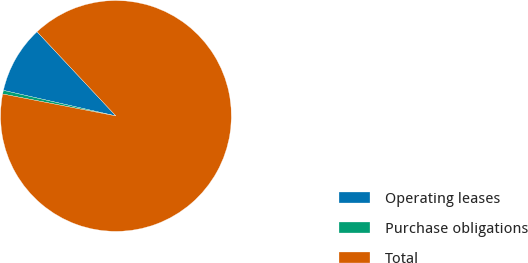Convert chart to OTSL. <chart><loc_0><loc_0><loc_500><loc_500><pie_chart><fcel>Operating leases<fcel>Purchase obligations<fcel>Total<nl><fcel>9.46%<fcel>0.51%<fcel>90.02%<nl></chart> 